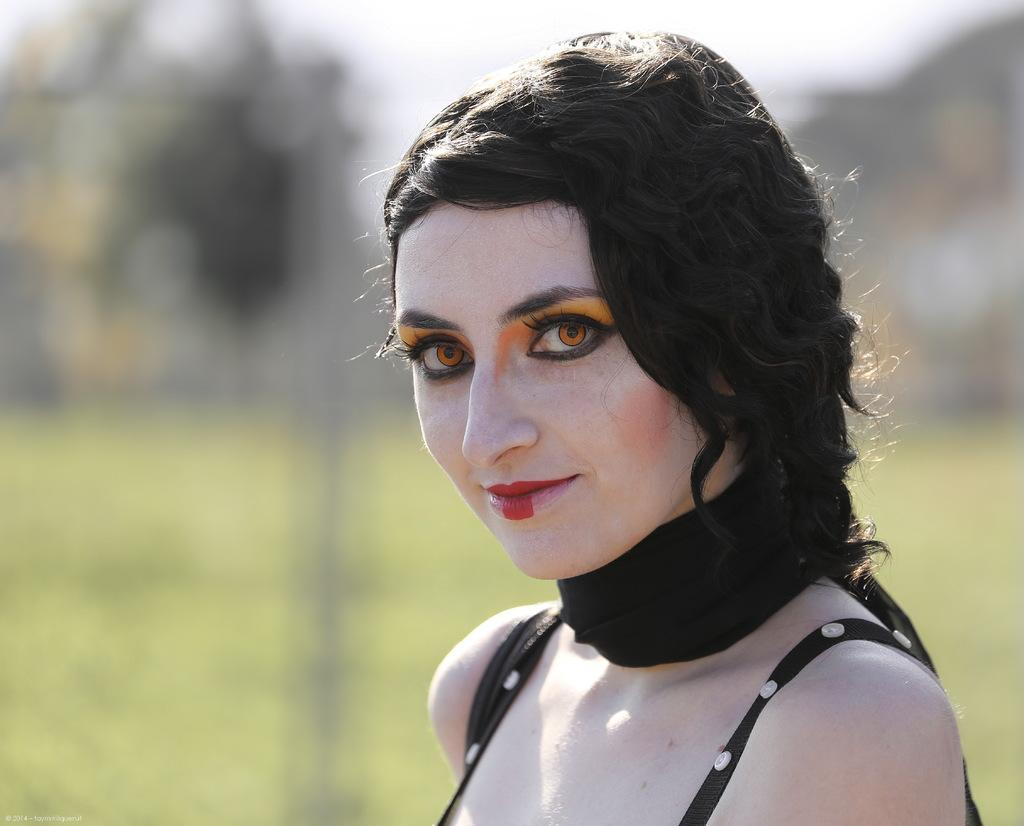Who is the main subject in the picture? There is a woman in the picture. What can be observed about the woman's appearance? The woman is wearing makeup. What is the woman wearing around her neck? There is a black cloth around the neck of the woman. Can you describe the background of the image? The background of the image is blurry. What type of card is the woman holding in the image? There is no card present in the image; the woman is not holding anything. 